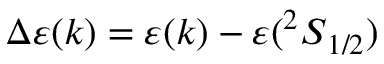<formula> <loc_0><loc_0><loc_500><loc_500>\Delta \varepsilon ( k ) = \varepsilon ( k ) - \varepsilon ( { ^ { 2 } S } _ { 1 / 2 } )</formula> 